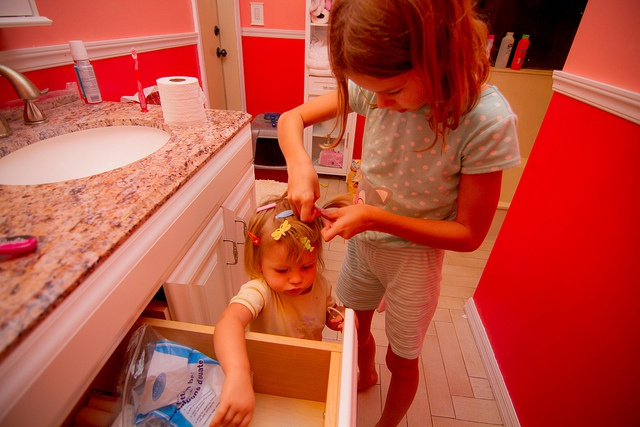Describe the objects in this image and their specific colors. I can see people in gray, maroon, and brown tones, people in gray, red, brown, and salmon tones, sink in gray, pink, lightpink, and salmon tones, and toothbrush in gray, red, salmon, and lightpink tones in this image. 